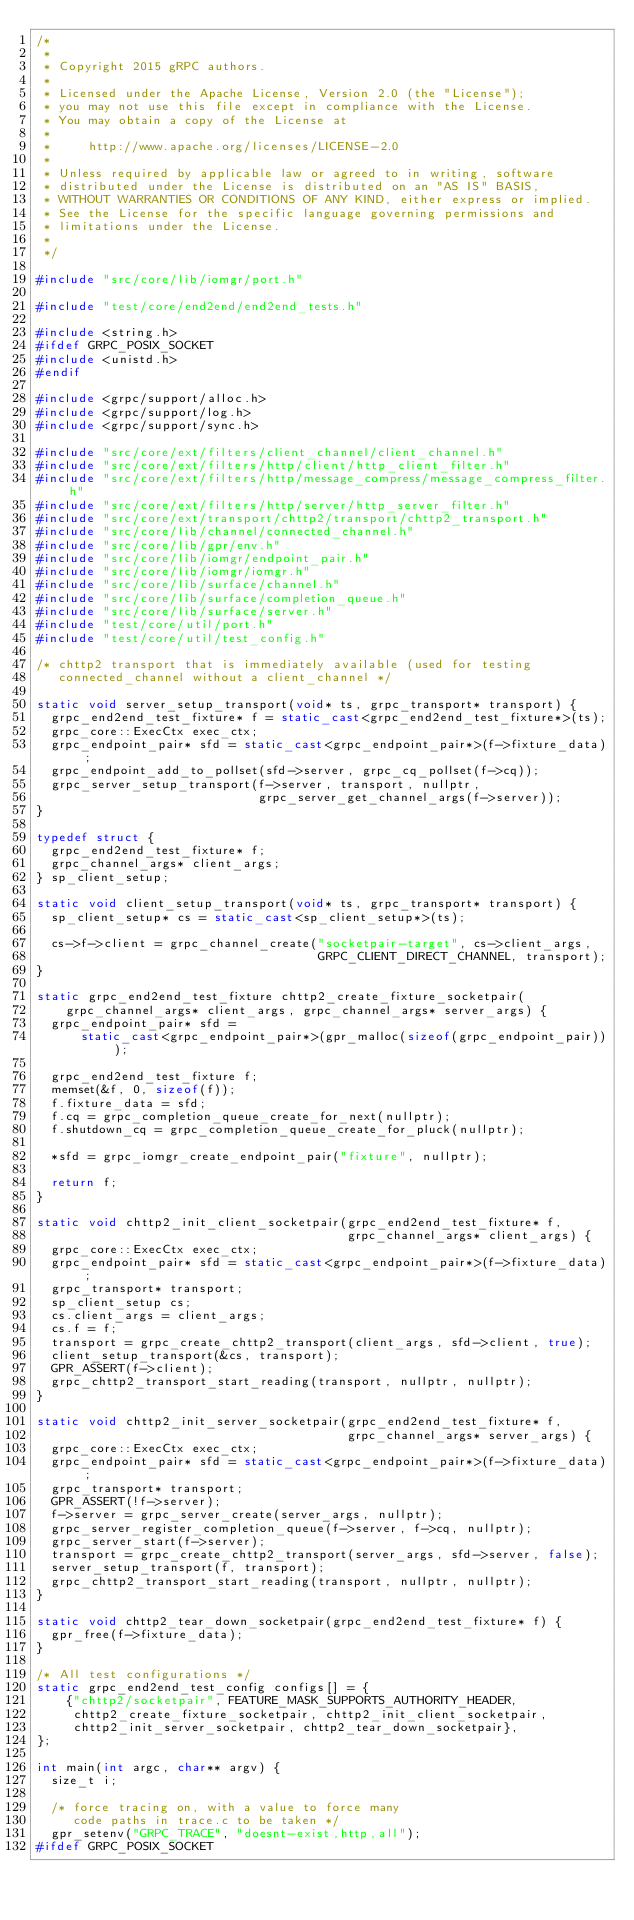Convert code to text. <code><loc_0><loc_0><loc_500><loc_500><_C++_>/*
 *
 * Copyright 2015 gRPC authors.
 *
 * Licensed under the Apache License, Version 2.0 (the "License");
 * you may not use this file except in compliance with the License.
 * You may obtain a copy of the License at
 *
 *     http://www.apache.org/licenses/LICENSE-2.0
 *
 * Unless required by applicable law or agreed to in writing, software
 * distributed under the License is distributed on an "AS IS" BASIS,
 * WITHOUT WARRANTIES OR CONDITIONS OF ANY KIND, either express or implied.
 * See the License for the specific language governing permissions and
 * limitations under the License.
 *
 */

#include "src/core/lib/iomgr/port.h"

#include "test/core/end2end/end2end_tests.h"

#include <string.h>
#ifdef GRPC_POSIX_SOCKET
#include <unistd.h>
#endif

#include <grpc/support/alloc.h>
#include <grpc/support/log.h>
#include <grpc/support/sync.h>

#include "src/core/ext/filters/client_channel/client_channel.h"
#include "src/core/ext/filters/http/client/http_client_filter.h"
#include "src/core/ext/filters/http/message_compress/message_compress_filter.h"
#include "src/core/ext/filters/http/server/http_server_filter.h"
#include "src/core/ext/transport/chttp2/transport/chttp2_transport.h"
#include "src/core/lib/channel/connected_channel.h"
#include "src/core/lib/gpr/env.h"
#include "src/core/lib/iomgr/endpoint_pair.h"
#include "src/core/lib/iomgr/iomgr.h"
#include "src/core/lib/surface/channel.h"
#include "src/core/lib/surface/completion_queue.h"
#include "src/core/lib/surface/server.h"
#include "test/core/util/port.h"
#include "test/core/util/test_config.h"

/* chttp2 transport that is immediately available (used for testing
   connected_channel without a client_channel */

static void server_setup_transport(void* ts, grpc_transport* transport) {
  grpc_end2end_test_fixture* f = static_cast<grpc_end2end_test_fixture*>(ts);
  grpc_core::ExecCtx exec_ctx;
  grpc_endpoint_pair* sfd = static_cast<grpc_endpoint_pair*>(f->fixture_data);
  grpc_endpoint_add_to_pollset(sfd->server, grpc_cq_pollset(f->cq));
  grpc_server_setup_transport(f->server, transport, nullptr,
                              grpc_server_get_channel_args(f->server));
}

typedef struct {
  grpc_end2end_test_fixture* f;
  grpc_channel_args* client_args;
} sp_client_setup;

static void client_setup_transport(void* ts, grpc_transport* transport) {
  sp_client_setup* cs = static_cast<sp_client_setup*>(ts);

  cs->f->client = grpc_channel_create("socketpair-target", cs->client_args,
                                      GRPC_CLIENT_DIRECT_CHANNEL, transport);
}

static grpc_end2end_test_fixture chttp2_create_fixture_socketpair(
    grpc_channel_args* client_args, grpc_channel_args* server_args) {
  grpc_endpoint_pair* sfd =
      static_cast<grpc_endpoint_pair*>(gpr_malloc(sizeof(grpc_endpoint_pair)));

  grpc_end2end_test_fixture f;
  memset(&f, 0, sizeof(f));
  f.fixture_data = sfd;
  f.cq = grpc_completion_queue_create_for_next(nullptr);
  f.shutdown_cq = grpc_completion_queue_create_for_pluck(nullptr);

  *sfd = grpc_iomgr_create_endpoint_pair("fixture", nullptr);

  return f;
}

static void chttp2_init_client_socketpair(grpc_end2end_test_fixture* f,
                                          grpc_channel_args* client_args) {
  grpc_core::ExecCtx exec_ctx;
  grpc_endpoint_pair* sfd = static_cast<grpc_endpoint_pair*>(f->fixture_data);
  grpc_transport* transport;
  sp_client_setup cs;
  cs.client_args = client_args;
  cs.f = f;
  transport = grpc_create_chttp2_transport(client_args, sfd->client, true);
  client_setup_transport(&cs, transport);
  GPR_ASSERT(f->client);
  grpc_chttp2_transport_start_reading(transport, nullptr, nullptr);
}

static void chttp2_init_server_socketpair(grpc_end2end_test_fixture* f,
                                          grpc_channel_args* server_args) {
  grpc_core::ExecCtx exec_ctx;
  grpc_endpoint_pair* sfd = static_cast<grpc_endpoint_pair*>(f->fixture_data);
  grpc_transport* transport;
  GPR_ASSERT(!f->server);
  f->server = grpc_server_create(server_args, nullptr);
  grpc_server_register_completion_queue(f->server, f->cq, nullptr);
  grpc_server_start(f->server);
  transport = grpc_create_chttp2_transport(server_args, sfd->server, false);
  server_setup_transport(f, transport);
  grpc_chttp2_transport_start_reading(transport, nullptr, nullptr);
}

static void chttp2_tear_down_socketpair(grpc_end2end_test_fixture* f) {
  gpr_free(f->fixture_data);
}

/* All test configurations */
static grpc_end2end_test_config configs[] = {
    {"chttp2/socketpair", FEATURE_MASK_SUPPORTS_AUTHORITY_HEADER,
     chttp2_create_fixture_socketpair, chttp2_init_client_socketpair,
     chttp2_init_server_socketpair, chttp2_tear_down_socketpair},
};

int main(int argc, char** argv) {
  size_t i;

  /* force tracing on, with a value to force many
     code paths in trace.c to be taken */
  gpr_setenv("GRPC_TRACE", "doesnt-exist,http,all");
#ifdef GRPC_POSIX_SOCKET</code> 